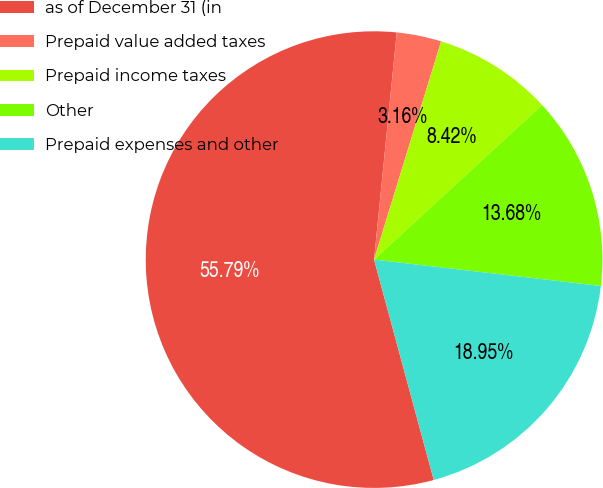Convert chart to OTSL. <chart><loc_0><loc_0><loc_500><loc_500><pie_chart><fcel>as of December 31 (in<fcel>Prepaid value added taxes<fcel>Prepaid income taxes<fcel>Other<fcel>Prepaid expenses and other<nl><fcel>55.8%<fcel>3.16%<fcel>8.42%<fcel>13.68%<fcel>18.95%<nl></chart> 